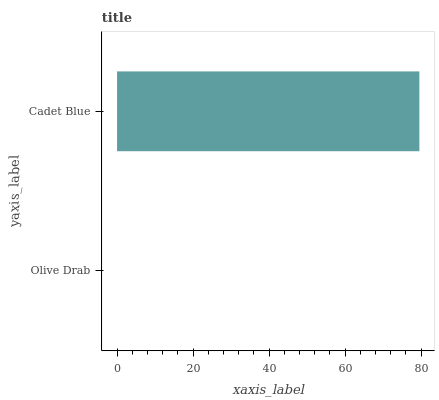Is Olive Drab the minimum?
Answer yes or no. Yes. Is Cadet Blue the maximum?
Answer yes or no. Yes. Is Cadet Blue the minimum?
Answer yes or no. No. Is Cadet Blue greater than Olive Drab?
Answer yes or no. Yes. Is Olive Drab less than Cadet Blue?
Answer yes or no. Yes. Is Olive Drab greater than Cadet Blue?
Answer yes or no. No. Is Cadet Blue less than Olive Drab?
Answer yes or no. No. Is Cadet Blue the high median?
Answer yes or no. Yes. Is Olive Drab the low median?
Answer yes or no. Yes. Is Olive Drab the high median?
Answer yes or no. No. Is Cadet Blue the low median?
Answer yes or no. No. 